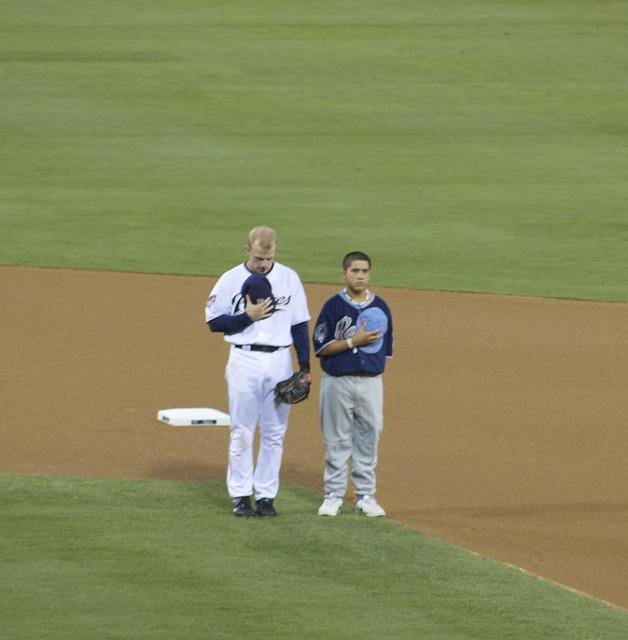Are both men running?
Short answer required. No. Is the referee coming?
Be succinct. No. Could this be a park?
Give a very brief answer. No. Do you see an umpire?
Keep it brief. No. Is this home base?
Quick response, please. No. Is the man in the white uniform on the left exercising?
Concise answer only. No. What is the Player's name?
Be succinct. No clue. What team does the man play for?
Give a very brief answer. Padres. Are both their heads bowed?
Short answer required. No. Which sport is this?
Answer briefly. Baseball. What are the two men doing with their hats?
Be succinct. Holding them over their hearts. Do their uniforms match?
Short answer required. No. 